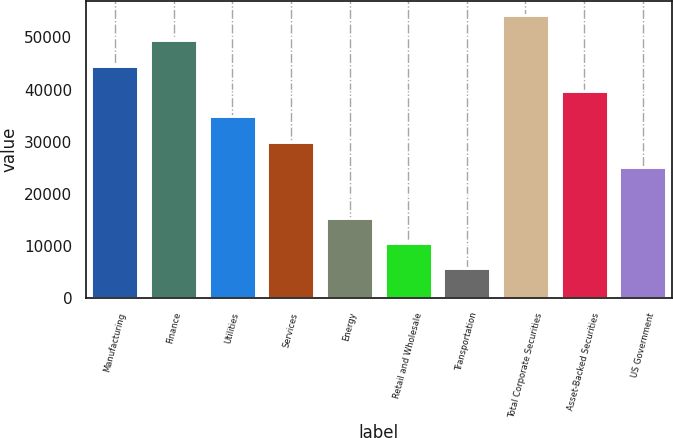<chart> <loc_0><loc_0><loc_500><loc_500><bar_chart><fcel>Manufacturing<fcel>Finance<fcel>Utilities<fcel>Services<fcel>Energy<fcel>Retail and Wholesale<fcel>Transportation<fcel>Total Corporate Securities<fcel>Asset-Backed Securities<fcel>US Government<nl><fcel>44608.9<fcel>49466<fcel>34894.7<fcel>30037.6<fcel>15466.3<fcel>10609.2<fcel>5752.1<fcel>54323.1<fcel>39751.8<fcel>25180.5<nl></chart> 